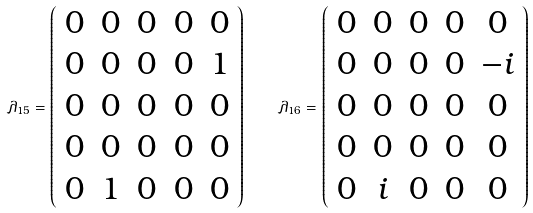<formula> <loc_0><loc_0><loc_500><loc_500>\lambda _ { 1 5 } = \left ( \begin{array} { c c c c c } 0 & 0 & 0 & 0 & 0 \\ 0 & 0 & 0 & 0 & 1 \\ 0 & 0 & 0 & 0 & 0 \\ 0 & 0 & 0 & 0 & 0 \\ 0 & 1 & 0 & 0 & 0 \end{array} \right ) \quad \lambda _ { 1 6 } = \left ( \begin{array} { c c c c c } 0 & 0 & 0 & 0 & 0 \\ 0 & 0 & 0 & 0 & - i \\ 0 & 0 & 0 & 0 & 0 \\ 0 & 0 & 0 & 0 & 0 \\ 0 & i & 0 & 0 & 0 \end{array} \right )</formula> 